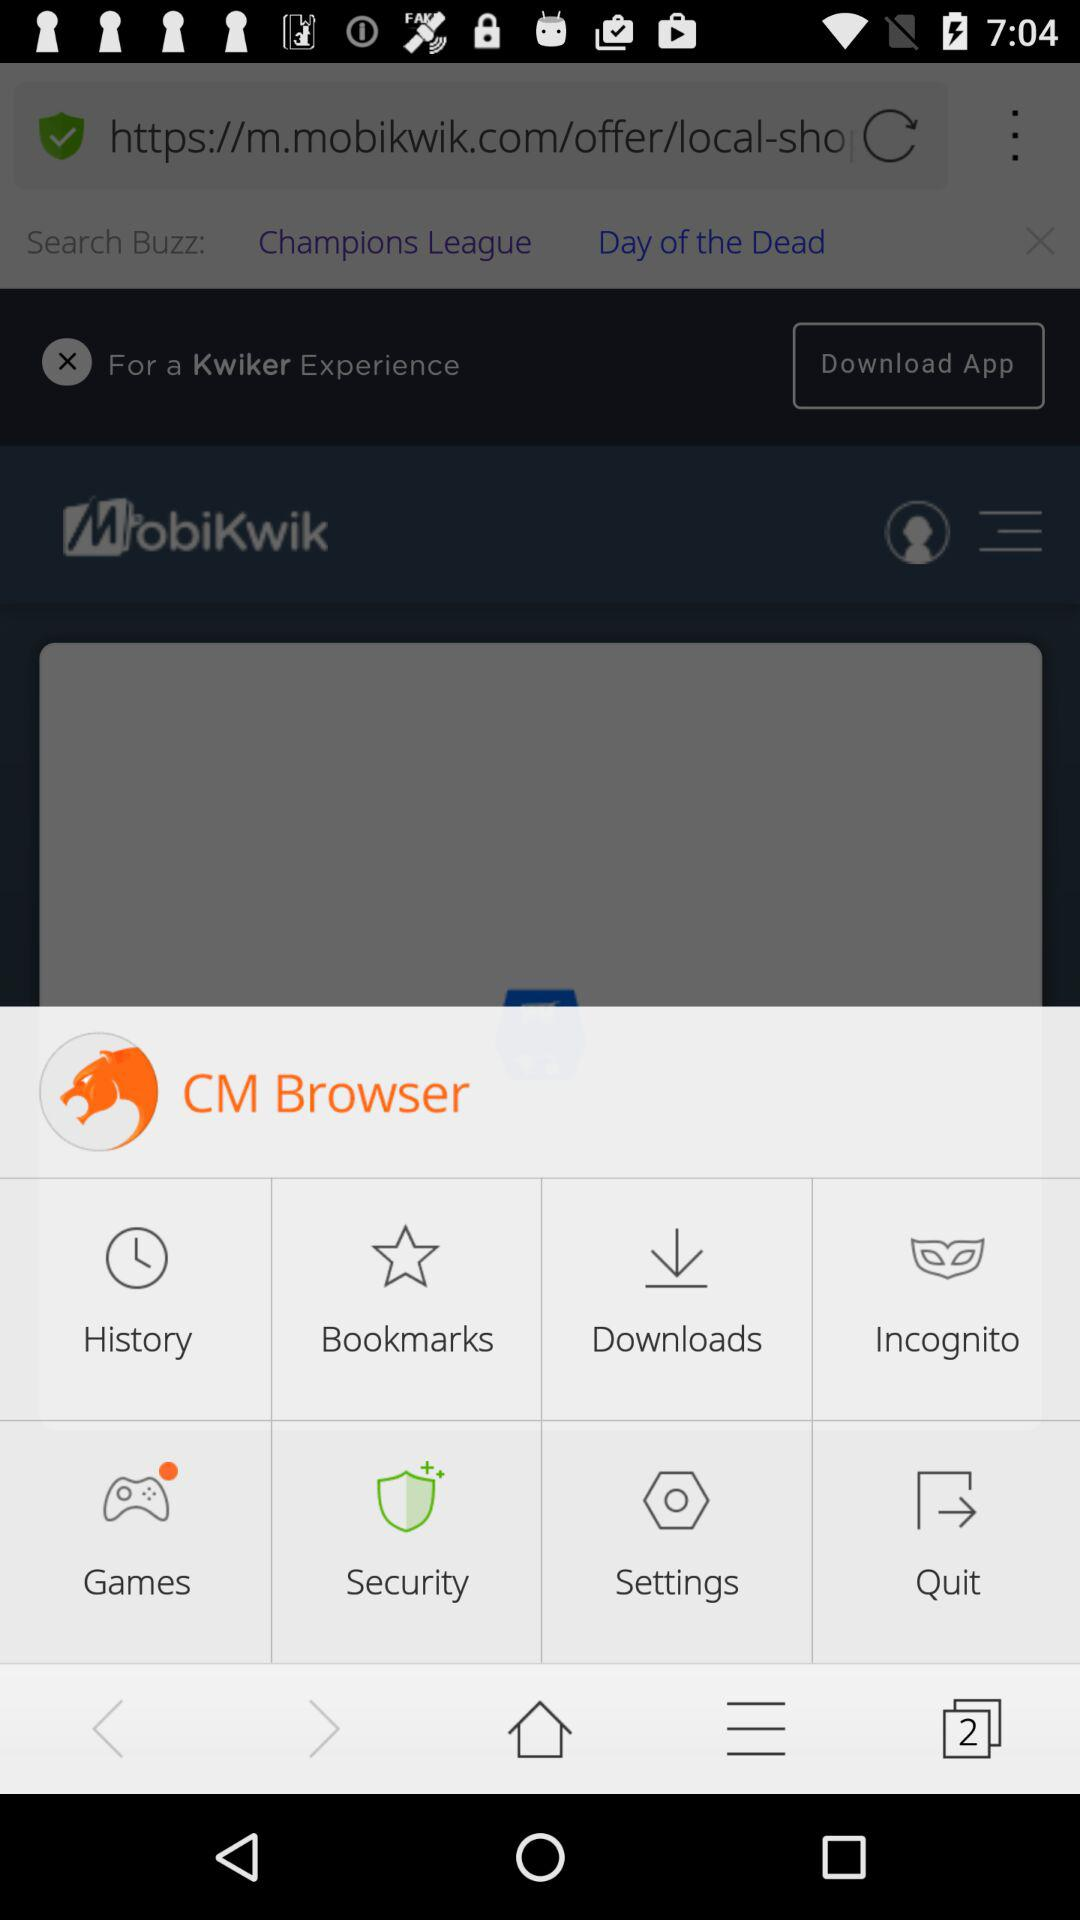What is the application name in the foreground? The application name in the foreground is "CM Browser". 